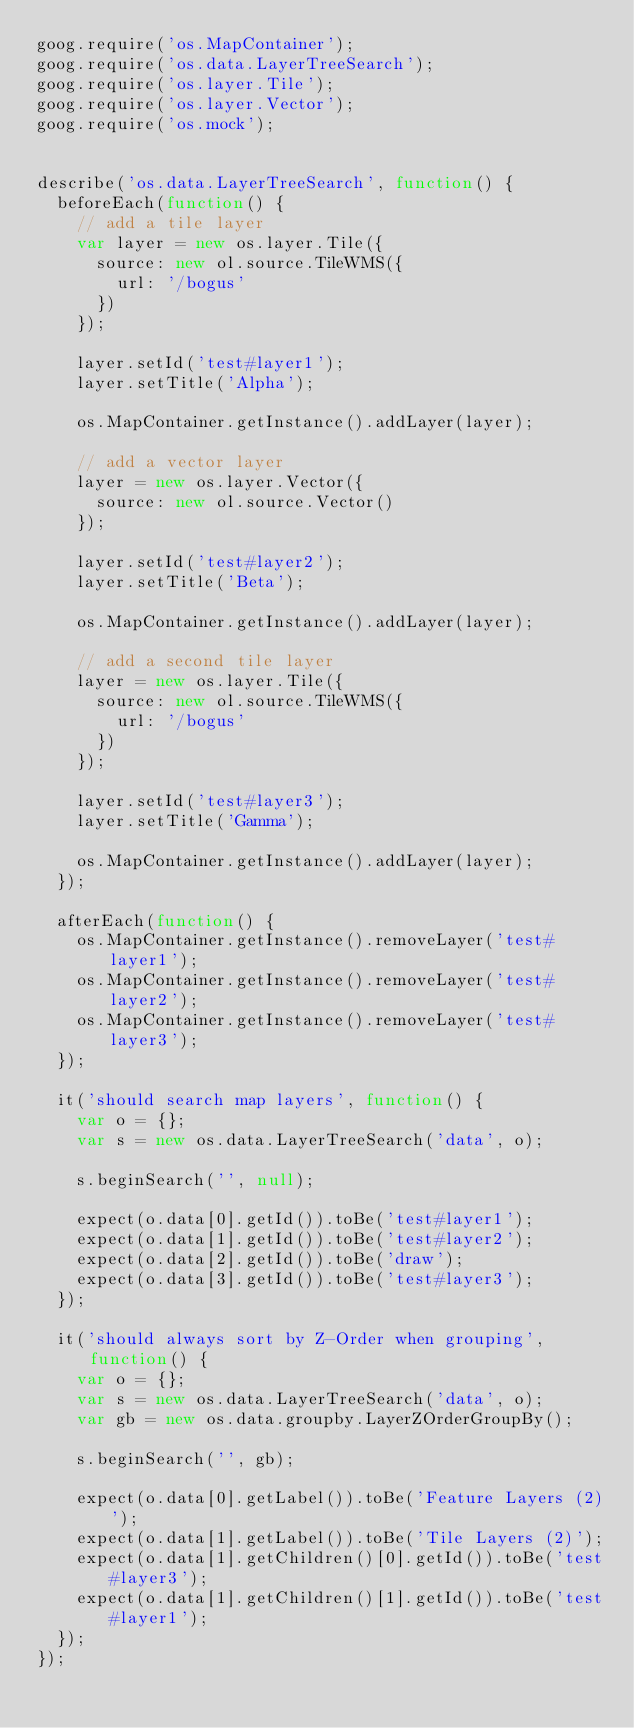Convert code to text. <code><loc_0><loc_0><loc_500><loc_500><_JavaScript_>goog.require('os.MapContainer');
goog.require('os.data.LayerTreeSearch');
goog.require('os.layer.Tile');
goog.require('os.layer.Vector');
goog.require('os.mock');


describe('os.data.LayerTreeSearch', function() {
  beforeEach(function() {
    // add a tile layer
    var layer = new os.layer.Tile({
      source: new ol.source.TileWMS({
        url: '/bogus'
      })
    });

    layer.setId('test#layer1');
    layer.setTitle('Alpha');

    os.MapContainer.getInstance().addLayer(layer);

    // add a vector layer
    layer = new os.layer.Vector({
      source: new ol.source.Vector()
    });

    layer.setId('test#layer2');
    layer.setTitle('Beta');

    os.MapContainer.getInstance().addLayer(layer);

    // add a second tile layer
    layer = new os.layer.Tile({
      source: new ol.source.TileWMS({
        url: '/bogus'
      })
    });

    layer.setId('test#layer3');
    layer.setTitle('Gamma');

    os.MapContainer.getInstance().addLayer(layer);
  });

  afterEach(function() {
    os.MapContainer.getInstance().removeLayer('test#layer1');
    os.MapContainer.getInstance().removeLayer('test#layer2');
    os.MapContainer.getInstance().removeLayer('test#layer3');
  });

  it('should search map layers', function() {
    var o = {};
    var s = new os.data.LayerTreeSearch('data', o);

    s.beginSearch('', null);

    expect(o.data[0].getId()).toBe('test#layer1');
    expect(o.data[1].getId()).toBe('test#layer2');
    expect(o.data[2].getId()).toBe('draw');
    expect(o.data[3].getId()).toBe('test#layer3');
  });

  it('should always sort by Z-Order when grouping', function() {
    var o = {};
    var s = new os.data.LayerTreeSearch('data', o);
    var gb = new os.data.groupby.LayerZOrderGroupBy();

    s.beginSearch('', gb);

    expect(o.data[0].getLabel()).toBe('Feature Layers (2)');
    expect(o.data[1].getLabel()).toBe('Tile Layers (2)');
    expect(o.data[1].getChildren()[0].getId()).toBe('test#layer3');
    expect(o.data[1].getChildren()[1].getId()).toBe('test#layer1');
  });
});
</code> 